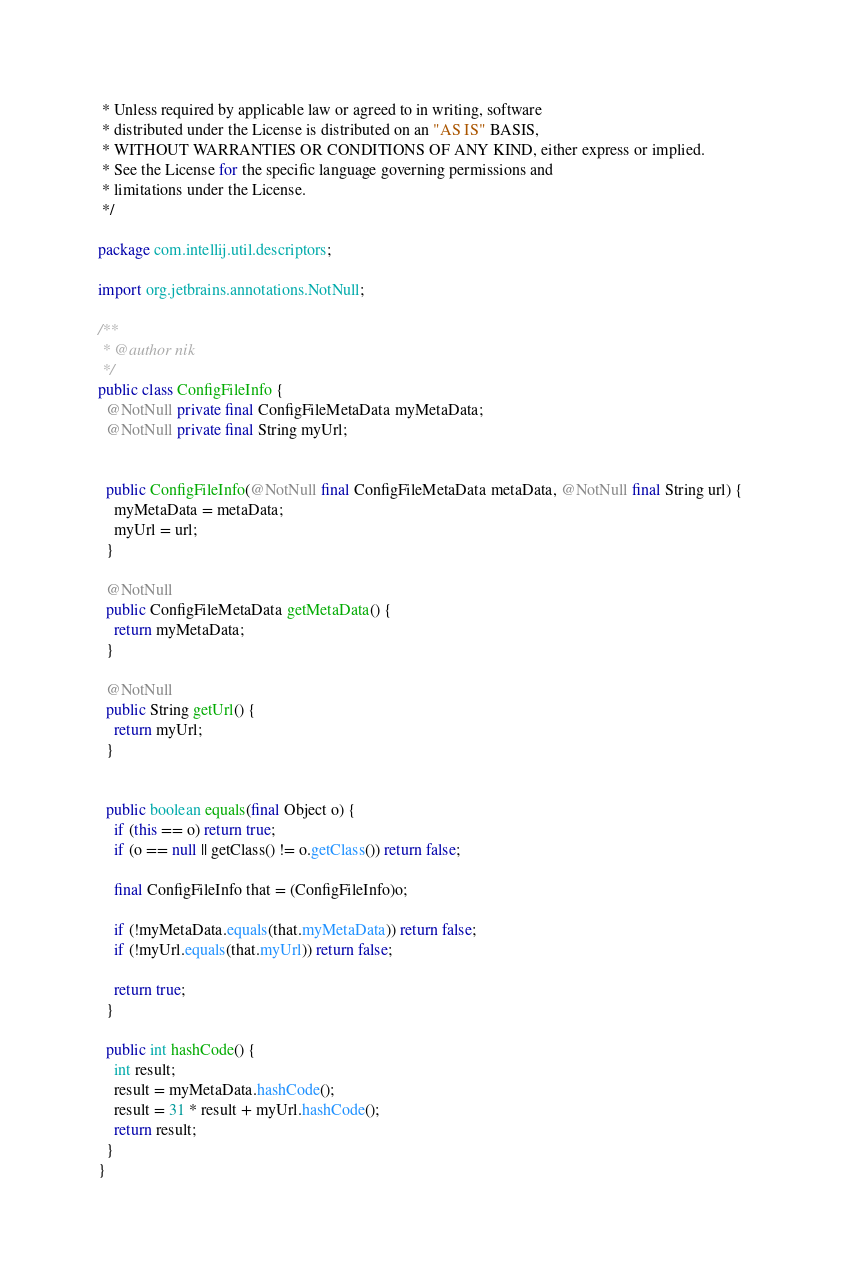<code> <loc_0><loc_0><loc_500><loc_500><_Java_> * Unless required by applicable law or agreed to in writing, software
 * distributed under the License is distributed on an "AS IS" BASIS,
 * WITHOUT WARRANTIES OR CONDITIONS OF ANY KIND, either express or implied.
 * See the License for the specific language governing permissions and
 * limitations under the License.
 */

package com.intellij.util.descriptors;

import org.jetbrains.annotations.NotNull;

/**
 * @author nik
 */
public class ConfigFileInfo {
  @NotNull private final ConfigFileMetaData myMetaData;
  @NotNull private final String myUrl;


  public ConfigFileInfo(@NotNull final ConfigFileMetaData metaData, @NotNull final String url) {
    myMetaData = metaData;
    myUrl = url;
  }

  @NotNull
  public ConfigFileMetaData getMetaData() {
    return myMetaData;
  }

  @NotNull
  public String getUrl() {
    return myUrl;
  }


  public boolean equals(final Object o) {
    if (this == o) return true;
    if (o == null || getClass() != o.getClass()) return false;

    final ConfigFileInfo that = (ConfigFileInfo)o;

    if (!myMetaData.equals(that.myMetaData)) return false;
    if (!myUrl.equals(that.myUrl)) return false;

    return true;
  }

  public int hashCode() {
    int result;
    result = myMetaData.hashCode();
    result = 31 * result + myUrl.hashCode();
    return result;
  }
}
</code> 